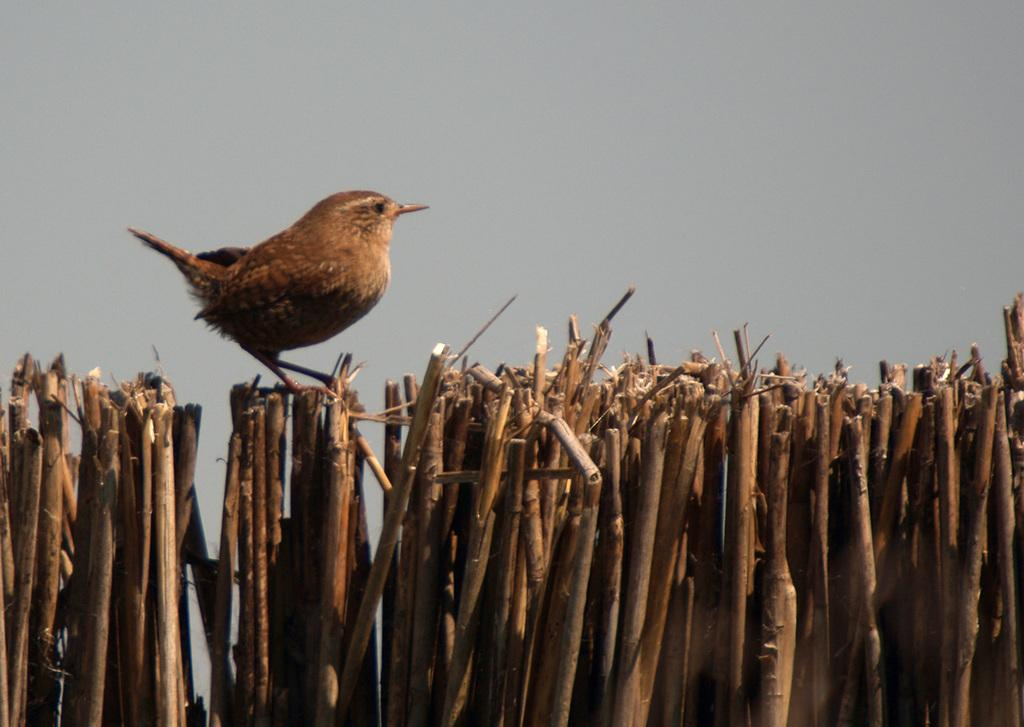What is located in the foreground of the image? There is a group of wooden sticks in the foreground of the image. How are the wooden sticks arranged? The wooden sticks are placed in an order. What can be seen on the wooden sticks? There is a bird on the wooden sticks. What is visible in the background of the image? The sky is visible in the image. What is the condition of the sky in the image? The sky appears to be cloudy. How many trucks can be seen in the image? There are no trucks present in the image. 